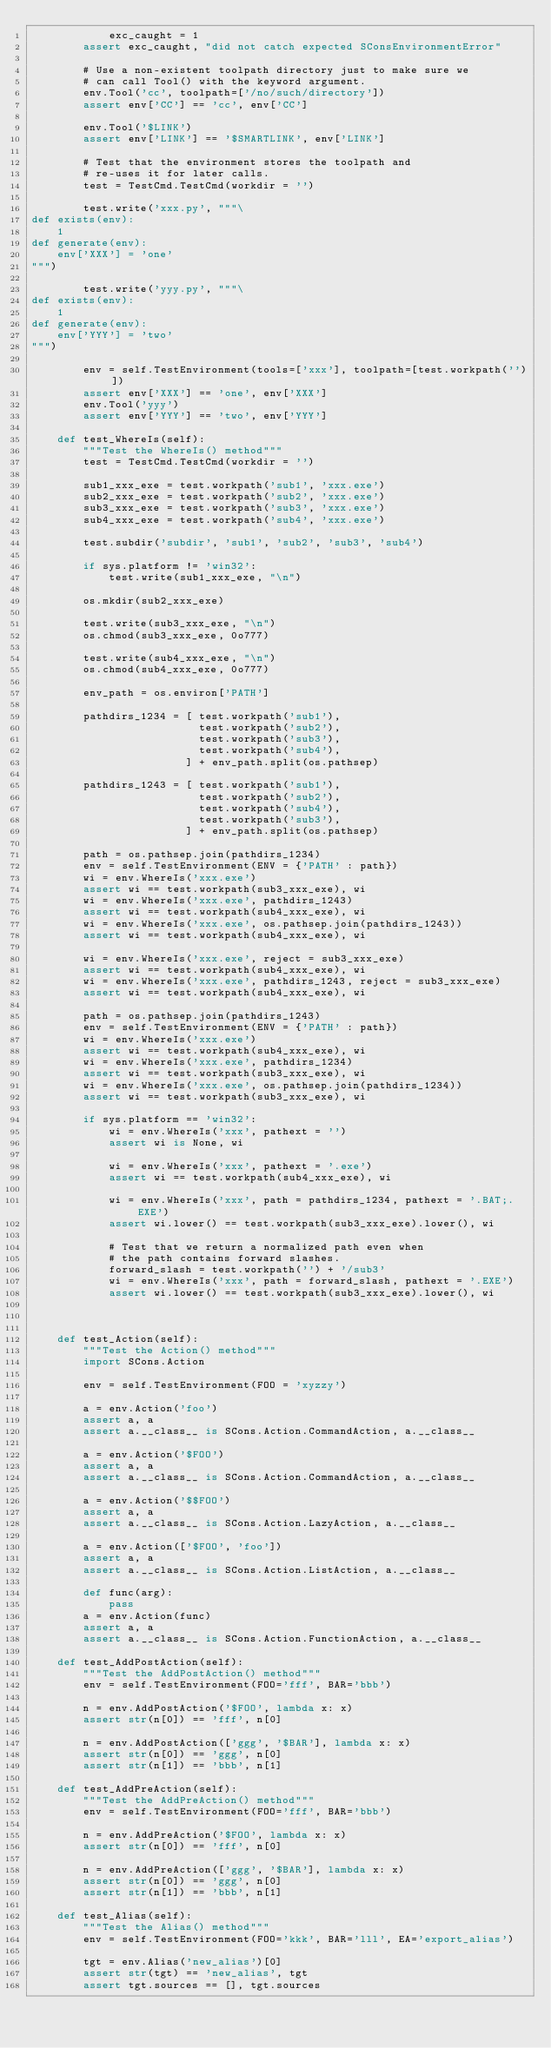<code> <loc_0><loc_0><loc_500><loc_500><_Python_>            exc_caught = 1
        assert exc_caught, "did not catch expected SConsEnvironmentError"

        # Use a non-existent toolpath directory just to make sure we
        # can call Tool() with the keyword argument.
        env.Tool('cc', toolpath=['/no/such/directory'])
        assert env['CC'] == 'cc', env['CC']

        env.Tool('$LINK')
        assert env['LINK'] == '$SMARTLINK', env['LINK']

        # Test that the environment stores the toolpath and
        # re-uses it for later calls.
        test = TestCmd.TestCmd(workdir = '')

        test.write('xxx.py', """\
def exists(env):
    1
def generate(env):
    env['XXX'] = 'one'
""")

        test.write('yyy.py', """\
def exists(env):
    1
def generate(env):
    env['YYY'] = 'two'
""")

        env = self.TestEnvironment(tools=['xxx'], toolpath=[test.workpath('')])
        assert env['XXX'] == 'one', env['XXX']
        env.Tool('yyy')
        assert env['YYY'] == 'two', env['YYY']

    def test_WhereIs(self):
        """Test the WhereIs() method"""
        test = TestCmd.TestCmd(workdir = '')

        sub1_xxx_exe = test.workpath('sub1', 'xxx.exe')
        sub2_xxx_exe = test.workpath('sub2', 'xxx.exe')
        sub3_xxx_exe = test.workpath('sub3', 'xxx.exe')
        sub4_xxx_exe = test.workpath('sub4', 'xxx.exe')

        test.subdir('subdir', 'sub1', 'sub2', 'sub3', 'sub4')

        if sys.platform != 'win32':
            test.write(sub1_xxx_exe, "\n")

        os.mkdir(sub2_xxx_exe)

        test.write(sub3_xxx_exe, "\n")
        os.chmod(sub3_xxx_exe, 0o777)

        test.write(sub4_xxx_exe, "\n")
        os.chmod(sub4_xxx_exe, 0o777)

        env_path = os.environ['PATH']

        pathdirs_1234 = [ test.workpath('sub1'),
                          test.workpath('sub2'),
                          test.workpath('sub3'),
                          test.workpath('sub4'),
                        ] + env_path.split(os.pathsep)

        pathdirs_1243 = [ test.workpath('sub1'),
                          test.workpath('sub2'),
                          test.workpath('sub4'),
                          test.workpath('sub3'),
                        ] + env_path.split(os.pathsep)

        path = os.pathsep.join(pathdirs_1234)
        env = self.TestEnvironment(ENV = {'PATH' : path})
        wi = env.WhereIs('xxx.exe')
        assert wi == test.workpath(sub3_xxx_exe), wi
        wi = env.WhereIs('xxx.exe', pathdirs_1243)
        assert wi == test.workpath(sub4_xxx_exe), wi
        wi = env.WhereIs('xxx.exe', os.pathsep.join(pathdirs_1243))
        assert wi == test.workpath(sub4_xxx_exe), wi

        wi = env.WhereIs('xxx.exe', reject = sub3_xxx_exe)
        assert wi == test.workpath(sub4_xxx_exe), wi
        wi = env.WhereIs('xxx.exe', pathdirs_1243, reject = sub3_xxx_exe)
        assert wi == test.workpath(sub4_xxx_exe), wi

        path = os.pathsep.join(pathdirs_1243)
        env = self.TestEnvironment(ENV = {'PATH' : path})
        wi = env.WhereIs('xxx.exe')
        assert wi == test.workpath(sub4_xxx_exe), wi
        wi = env.WhereIs('xxx.exe', pathdirs_1234)
        assert wi == test.workpath(sub3_xxx_exe), wi
        wi = env.WhereIs('xxx.exe', os.pathsep.join(pathdirs_1234))
        assert wi == test.workpath(sub3_xxx_exe), wi

        if sys.platform == 'win32':
            wi = env.WhereIs('xxx', pathext = '')
            assert wi is None, wi

            wi = env.WhereIs('xxx', pathext = '.exe')
            assert wi == test.workpath(sub4_xxx_exe), wi

            wi = env.WhereIs('xxx', path = pathdirs_1234, pathext = '.BAT;.EXE')
            assert wi.lower() == test.workpath(sub3_xxx_exe).lower(), wi

            # Test that we return a normalized path even when
            # the path contains forward slashes.
            forward_slash = test.workpath('') + '/sub3'
            wi = env.WhereIs('xxx', path = forward_slash, pathext = '.EXE')
            assert wi.lower() == test.workpath(sub3_xxx_exe).lower(), wi



    def test_Action(self):
        """Test the Action() method"""
        import SCons.Action

        env = self.TestEnvironment(FOO = 'xyzzy')

        a = env.Action('foo')
        assert a, a
        assert a.__class__ is SCons.Action.CommandAction, a.__class__

        a = env.Action('$FOO')
        assert a, a
        assert a.__class__ is SCons.Action.CommandAction, a.__class__

        a = env.Action('$$FOO')
        assert a, a
        assert a.__class__ is SCons.Action.LazyAction, a.__class__

        a = env.Action(['$FOO', 'foo'])
        assert a, a
        assert a.__class__ is SCons.Action.ListAction, a.__class__

        def func(arg):
            pass
        a = env.Action(func)
        assert a, a
        assert a.__class__ is SCons.Action.FunctionAction, a.__class__

    def test_AddPostAction(self):
        """Test the AddPostAction() method"""
        env = self.TestEnvironment(FOO='fff', BAR='bbb')

        n = env.AddPostAction('$FOO', lambda x: x)
        assert str(n[0]) == 'fff', n[0]

        n = env.AddPostAction(['ggg', '$BAR'], lambda x: x)
        assert str(n[0]) == 'ggg', n[0]
        assert str(n[1]) == 'bbb', n[1]

    def test_AddPreAction(self):
        """Test the AddPreAction() method"""
        env = self.TestEnvironment(FOO='fff', BAR='bbb')

        n = env.AddPreAction('$FOO', lambda x: x)
        assert str(n[0]) == 'fff', n[0]

        n = env.AddPreAction(['ggg', '$BAR'], lambda x: x)
        assert str(n[0]) == 'ggg', n[0]
        assert str(n[1]) == 'bbb', n[1]

    def test_Alias(self):
        """Test the Alias() method"""
        env = self.TestEnvironment(FOO='kkk', BAR='lll', EA='export_alias')

        tgt = env.Alias('new_alias')[0]
        assert str(tgt) == 'new_alias', tgt
        assert tgt.sources == [], tgt.sources</code> 